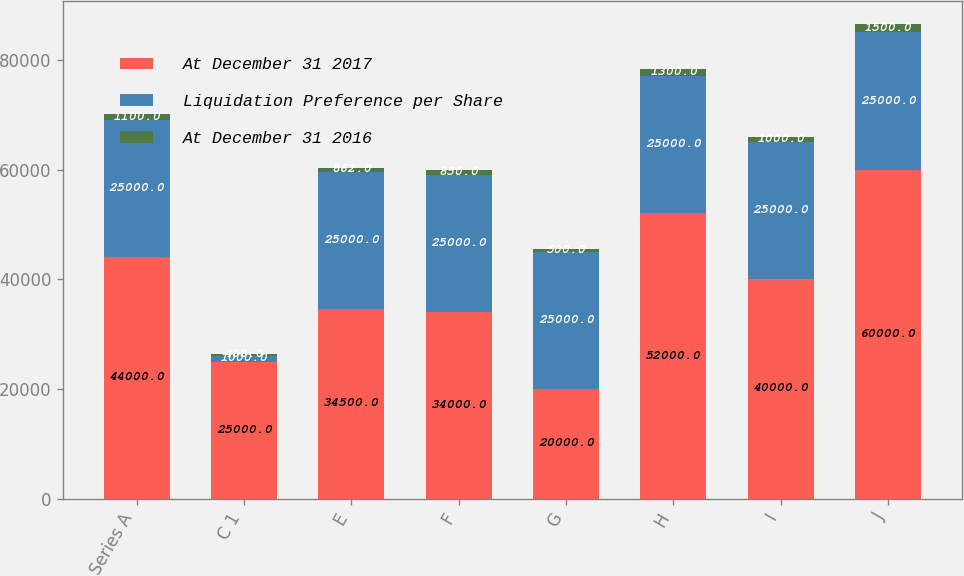<chart> <loc_0><loc_0><loc_500><loc_500><stacked_bar_chart><ecel><fcel>Series A<fcel>C 1<fcel>E<fcel>F<fcel>G<fcel>H<fcel>I<fcel>J<nl><fcel>At December 31 2017<fcel>44000<fcel>25000<fcel>34500<fcel>34000<fcel>20000<fcel>52000<fcel>40000<fcel>60000<nl><fcel>Liquidation Preference per Share<fcel>25000<fcel>1000<fcel>25000<fcel>25000<fcel>25000<fcel>25000<fcel>25000<fcel>25000<nl><fcel>At December 31 2016<fcel>1100<fcel>408<fcel>862<fcel>850<fcel>500<fcel>1300<fcel>1000<fcel>1500<nl></chart> 